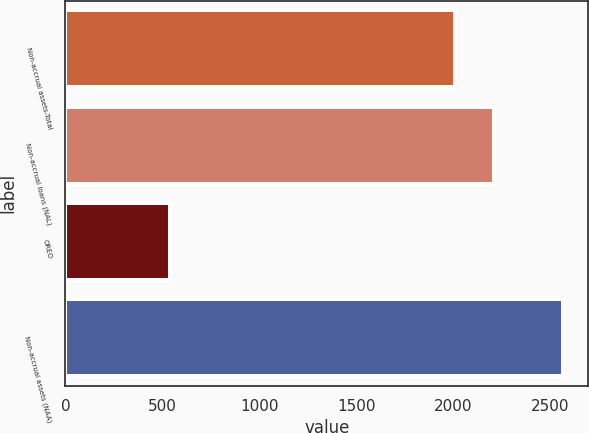Convert chart. <chart><loc_0><loc_0><loc_500><loc_500><bar_chart><fcel>Non-accrual assets-Total<fcel>Non-accrual loans (NAL)<fcel>OREO<fcel>Non-accrual assets (NAA)<nl><fcel>2007<fcel>2209.7<fcel>541<fcel>2568<nl></chart> 